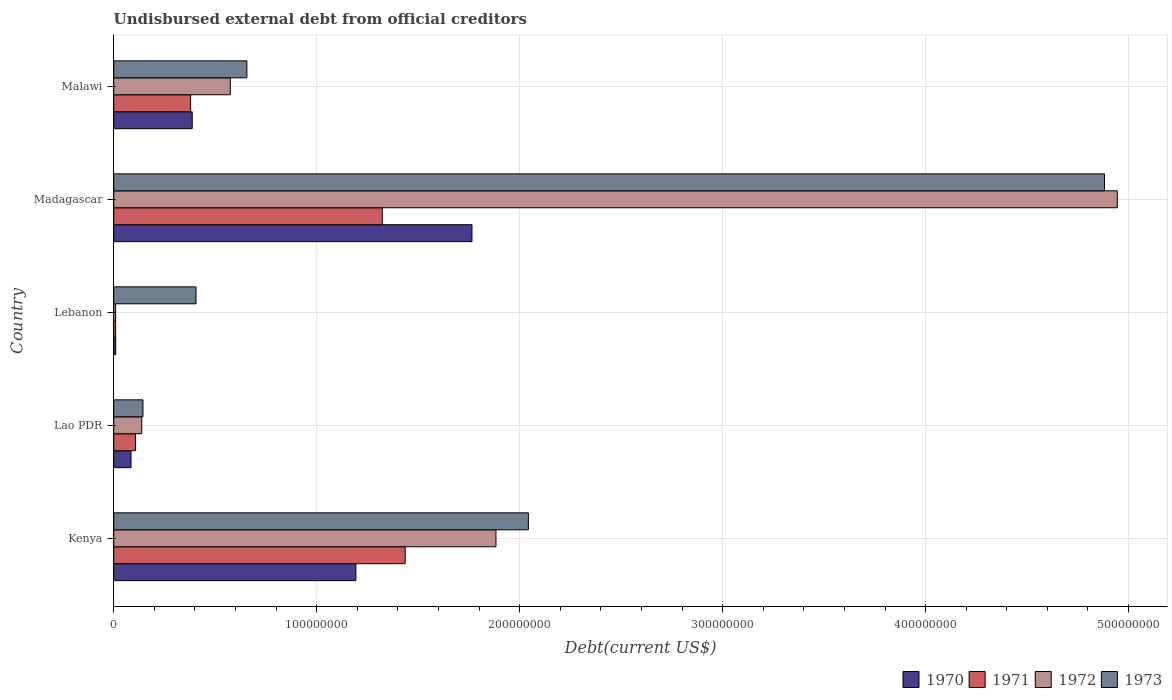Are the number of bars per tick equal to the number of legend labels?
Ensure brevity in your answer.  Yes. Are the number of bars on each tick of the Y-axis equal?
Your response must be concise. Yes. How many bars are there on the 4th tick from the bottom?
Keep it short and to the point. 4. What is the label of the 2nd group of bars from the top?
Ensure brevity in your answer.  Madagascar. In how many cases, is the number of bars for a given country not equal to the number of legend labels?
Offer a terse response. 0. What is the total debt in 1972 in Malawi?
Ensure brevity in your answer.  5.74e+07. Across all countries, what is the maximum total debt in 1971?
Your response must be concise. 1.44e+08. Across all countries, what is the minimum total debt in 1971?
Give a very brief answer. 9.32e+05. In which country was the total debt in 1970 maximum?
Your answer should be very brief. Madagascar. In which country was the total debt in 1970 minimum?
Make the answer very short. Lebanon. What is the total total debt in 1973 in the graph?
Make the answer very short. 8.13e+08. What is the difference between the total debt in 1970 in Lebanon and that in Madagascar?
Offer a very short reply. -1.76e+08. What is the difference between the total debt in 1973 in Lao PDR and the total debt in 1972 in Kenya?
Offer a very short reply. -1.74e+08. What is the average total debt in 1973 per country?
Provide a short and direct response. 1.63e+08. What is the difference between the total debt in 1972 and total debt in 1971 in Lao PDR?
Your answer should be very brief. 3.08e+06. In how many countries, is the total debt in 1973 greater than 440000000 US$?
Make the answer very short. 1. What is the ratio of the total debt in 1973 in Kenya to that in Madagascar?
Your answer should be very brief. 0.42. What is the difference between the highest and the second highest total debt in 1971?
Offer a very short reply. 1.13e+07. What is the difference between the highest and the lowest total debt in 1972?
Offer a terse response. 4.94e+08. In how many countries, is the total debt in 1970 greater than the average total debt in 1970 taken over all countries?
Your answer should be very brief. 2. Is the sum of the total debt in 1971 in Kenya and Malawi greater than the maximum total debt in 1973 across all countries?
Offer a terse response. No. What does the 4th bar from the top in Madagascar represents?
Offer a very short reply. 1970. What does the 3rd bar from the bottom in Malawi represents?
Give a very brief answer. 1972. Is it the case that in every country, the sum of the total debt in 1970 and total debt in 1972 is greater than the total debt in 1971?
Your answer should be very brief. Yes. How many countries are there in the graph?
Offer a very short reply. 5. Does the graph contain any zero values?
Offer a terse response. No. Does the graph contain grids?
Make the answer very short. Yes. What is the title of the graph?
Provide a succinct answer. Undisbursed external debt from official creditors. What is the label or title of the X-axis?
Offer a very short reply. Debt(current US$). What is the Debt(current US$) of 1970 in Kenya?
Make the answer very short. 1.19e+08. What is the Debt(current US$) in 1971 in Kenya?
Your answer should be very brief. 1.44e+08. What is the Debt(current US$) in 1972 in Kenya?
Make the answer very short. 1.88e+08. What is the Debt(current US$) in 1973 in Kenya?
Offer a very short reply. 2.04e+08. What is the Debt(current US$) of 1970 in Lao PDR?
Keep it short and to the point. 8.52e+06. What is the Debt(current US$) in 1971 in Lao PDR?
Ensure brevity in your answer.  1.07e+07. What is the Debt(current US$) of 1972 in Lao PDR?
Offer a terse response. 1.38e+07. What is the Debt(current US$) in 1973 in Lao PDR?
Provide a short and direct response. 1.44e+07. What is the Debt(current US$) in 1970 in Lebanon?
Provide a short and direct response. 9.80e+05. What is the Debt(current US$) in 1971 in Lebanon?
Offer a very short reply. 9.32e+05. What is the Debt(current US$) of 1972 in Lebanon?
Your answer should be compact. 9.32e+05. What is the Debt(current US$) of 1973 in Lebanon?
Offer a terse response. 4.05e+07. What is the Debt(current US$) in 1970 in Madagascar?
Offer a very short reply. 1.76e+08. What is the Debt(current US$) of 1971 in Madagascar?
Your response must be concise. 1.32e+08. What is the Debt(current US$) of 1972 in Madagascar?
Your answer should be very brief. 4.94e+08. What is the Debt(current US$) in 1973 in Madagascar?
Offer a terse response. 4.88e+08. What is the Debt(current US$) in 1970 in Malawi?
Offer a very short reply. 3.87e+07. What is the Debt(current US$) in 1971 in Malawi?
Your answer should be compact. 3.79e+07. What is the Debt(current US$) in 1972 in Malawi?
Your answer should be compact. 5.74e+07. What is the Debt(current US$) in 1973 in Malawi?
Ensure brevity in your answer.  6.56e+07. Across all countries, what is the maximum Debt(current US$) in 1970?
Give a very brief answer. 1.76e+08. Across all countries, what is the maximum Debt(current US$) of 1971?
Provide a succinct answer. 1.44e+08. Across all countries, what is the maximum Debt(current US$) in 1972?
Your answer should be very brief. 4.94e+08. Across all countries, what is the maximum Debt(current US$) in 1973?
Make the answer very short. 4.88e+08. Across all countries, what is the minimum Debt(current US$) of 1970?
Make the answer very short. 9.80e+05. Across all countries, what is the minimum Debt(current US$) in 1971?
Your answer should be very brief. 9.32e+05. Across all countries, what is the minimum Debt(current US$) in 1972?
Keep it short and to the point. 9.32e+05. Across all countries, what is the minimum Debt(current US$) in 1973?
Make the answer very short. 1.44e+07. What is the total Debt(current US$) in 1970 in the graph?
Ensure brevity in your answer.  3.44e+08. What is the total Debt(current US$) of 1971 in the graph?
Offer a terse response. 3.25e+08. What is the total Debt(current US$) in 1972 in the graph?
Provide a succinct answer. 7.55e+08. What is the total Debt(current US$) in 1973 in the graph?
Keep it short and to the point. 8.13e+08. What is the difference between the Debt(current US$) of 1970 in Kenya and that in Lao PDR?
Provide a succinct answer. 1.11e+08. What is the difference between the Debt(current US$) of 1971 in Kenya and that in Lao PDR?
Your response must be concise. 1.33e+08. What is the difference between the Debt(current US$) of 1972 in Kenya and that in Lao PDR?
Your answer should be very brief. 1.75e+08. What is the difference between the Debt(current US$) of 1973 in Kenya and that in Lao PDR?
Keep it short and to the point. 1.90e+08. What is the difference between the Debt(current US$) of 1970 in Kenya and that in Lebanon?
Give a very brief answer. 1.18e+08. What is the difference between the Debt(current US$) of 1971 in Kenya and that in Lebanon?
Provide a succinct answer. 1.43e+08. What is the difference between the Debt(current US$) in 1972 in Kenya and that in Lebanon?
Provide a short and direct response. 1.87e+08. What is the difference between the Debt(current US$) in 1973 in Kenya and that in Lebanon?
Your answer should be very brief. 1.64e+08. What is the difference between the Debt(current US$) in 1970 in Kenya and that in Madagascar?
Provide a short and direct response. -5.72e+07. What is the difference between the Debt(current US$) in 1971 in Kenya and that in Madagascar?
Your answer should be compact. 1.13e+07. What is the difference between the Debt(current US$) of 1972 in Kenya and that in Madagascar?
Give a very brief answer. -3.06e+08. What is the difference between the Debt(current US$) in 1973 in Kenya and that in Madagascar?
Ensure brevity in your answer.  -2.84e+08. What is the difference between the Debt(current US$) in 1970 in Kenya and that in Malawi?
Keep it short and to the point. 8.06e+07. What is the difference between the Debt(current US$) of 1971 in Kenya and that in Malawi?
Your answer should be very brief. 1.06e+08. What is the difference between the Debt(current US$) of 1972 in Kenya and that in Malawi?
Offer a terse response. 1.31e+08. What is the difference between the Debt(current US$) of 1973 in Kenya and that in Malawi?
Make the answer very short. 1.39e+08. What is the difference between the Debt(current US$) of 1970 in Lao PDR and that in Lebanon?
Make the answer very short. 7.54e+06. What is the difference between the Debt(current US$) in 1971 in Lao PDR and that in Lebanon?
Offer a terse response. 9.78e+06. What is the difference between the Debt(current US$) of 1972 in Lao PDR and that in Lebanon?
Make the answer very short. 1.29e+07. What is the difference between the Debt(current US$) in 1973 in Lao PDR and that in Lebanon?
Make the answer very short. -2.61e+07. What is the difference between the Debt(current US$) in 1970 in Lao PDR and that in Madagascar?
Offer a very short reply. -1.68e+08. What is the difference between the Debt(current US$) of 1971 in Lao PDR and that in Madagascar?
Ensure brevity in your answer.  -1.22e+08. What is the difference between the Debt(current US$) in 1972 in Lao PDR and that in Madagascar?
Ensure brevity in your answer.  -4.81e+08. What is the difference between the Debt(current US$) of 1973 in Lao PDR and that in Madagascar?
Provide a succinct answer. -4.74e+08. What is the difference between the Debt(current US$) of 1970 in Lao PDR and that in Malawi?
Provide a short and direct response. -3.01e+07. What is the difference between the Debt(current US$) in 1971 in Lao PDR and that in Malawi?
Your response must be concise. -2.72e+07. What is the difference between the Debt(current US$) of 1972 in Lao PDR and that in Malawi?
Ensure brevity in your answer.  -4.36e+07. What is the difference between the Debt(current US$) in 1973 in Lao PDR and that in Malawi?
Provide a short and direct response. -5.12e+07. What is the difference between the Debt(current US$) in 1970 in Lebanon and that in Madagascar?
Your response must be concise. -1.76e+08. What is the difference between the Debt(current US$) of 1971 in Lebanon and that in Madagascar?
Give a very brief answer. -1.31e+08. What is the difference between the Debt(current US$) in 1972 in Lebanon and that in Madagascar?
Give a very brief answer. -4.94e+08. What is the difference between the Debt(current US$) in 1973 in Lebanon and that in Madagascar?
Give a very brief answer. -4.48e+08. What is the difference between the Debt(current US$) in 1970 in Lebanon and that in Malawi?
Provide a succinct answer. -3.77e+07. What is the difference between the Debt(current US$) in 1971 in Lebanon and that in Malawi?
Give a very brief answer. -3.70e+07. What is the difference between the Debt(current US$) in 1972 in Lebanon and that in Malawi?
Offer a very short reply. -5.65e+07. What is the difference between the Debt(current US$) in 1973 in Lebanon and that in Malawi?
Provide a short and direct response. -2.51e+07. What is the difference between the Debt(current US$) of 1970 in Madagascar and that in Malawi?
Give a very brief answer. 1.38e+08. What is the difference between the Debt(current US$) of 1971 in Madagascar and that in Malawi?
Your answer should be very brief. 9.44e+07. What is the difference between the Debt(current US$) of 1972 in Madagascar and that in Malawi?
Keep it short and to the point. 4.37e+08. What is the difference between the Debt(current US$) in 1973 in Madagascar and that in Malawi?
Provide a short and direct response. 4.23e+08. What is the difference between the Debt(current US$) in 1970 in Kenya and the Debt(current US$) in 1971 in Lao PDR?
Offer a very short reply. 1.09e+08. What is the difference between the Debt(current US$) of 1970 in Kenya and the Debt(current US$) of 1972 in Lao PDR?
Offer a very short reply. 1.05e+08. What is the difference between the Debt(current US$) of 1970 in Kenya and the Debt(current US$) of 1973 in Lao PDR?
Your answer should be compact. 1.05e+08. What is the difference between the Debt(current US$) in 1971 in Kenya and the Debt(current US$) in 1972 in Lao PDR?
Your answer should be compact. 1.30e+08. What is the difference between the Debt(current US$) in 1971 in Kenya and the Debt(current US$) in 1973 in Lao PDR?
Your answer should be compact. 1.29e+08. What is the difference between the Debt(current US$) of 1972 in Kenya and the Debt(current US$) of 1973 in Lao PDR?
Make the answer very short. 1.74e+08. What is the difference between the Debt(current US$) of 1970 in Kenya and the Debt(current US$) of 1971 in Lebanon?
Ensure brevity in your answer.  1.18e+08. What is the difference between the Debt(current US$) of 1970 in Kenya and the Debt(current US$) of 1972 in Lebanon?
Offer a terse response. 1.18e+08. What is the difference between the Debt(current US$) in 1970 in Kenya and the Debt(current US$) in 1973 in Lebanon?
Provide a succinct answer. 7.88e+07. What is the difference between the Debt(current US$) in 1971 in Kenya and the Debt(current US$) in 1972 in Lebanon?
Your response must be concise. 1.43e+08. What is the difference between the Debt(current US$) of 1971 in Kenya and the Debt(current US$) of 1973 in Lebanon?
Your answer should be very brief. 1.03e+08. What is the difference between the Debt(current US$) in 1972 in Kenya and the Debt(current US$) in 1973 in Lebanon?
Give a very brief answer. 1.48e+08. What is the difference between the Debt(current US$) in 1970 in Kenya and the Debt(current US$) in 1971 in Madagascar?
Your answer should be compact. -1.30e+07. What is the difference between the Debt(current US$) in 1970 in Kenya and the Debt(current US$) in 1972 in Madagascar?
Provide a succinct answer. -3.75e+08. What is the difference between the Debt(current US$) in 1970 in Kenya and the Debt(current US$) in 1973 in Madagascar?
Make the answer very short. -3.69e+08. What is the difference between the Debt(current US$) of 1971 in Kenya and the Debt(current US$) of 1972 in Madagascar?
Your answer should be very brief. -3.51e+08. What is the difference between the Debt(current US$) in 1971 in Kenya and the Debt(current US$) in 1973 in Madagascar?
Offer a very short reply. -3.45e+08. What is the difference between the Debt(current US$) in 1972 in Kenya and the Debt(current US$) in 1973 in Madagascar?
Offer a terse response. -3.00e+08. What is the difference between the Debt(current US$) in 1970 in Kenya and the Debt(current US$) in 1971 in Malawi?
Give a very brief answer. 8.14e+07. What is the difference between the Debt(current US$) of 1970 in Kenya and the Debt(current US$) of 1972 in Malawi?
Offer a terse response. 6.19e+07. What is the difference between the Debt(current US$) of 1970 in Kenya and the Debt(current US$) of 1973 in Malawi?
Provide a short and direct response. 5.37e+07. What is the difference between the Debt(current US$) in 1971 in Kenya and the Debt(current US$) in 1972 in Malawi?
Provide a succinct answer. 8.62e+07. What is the difference between the Debt(current US$) of 1971 in Kenya and the Debt(current US$) of 1973 in Malawi?
Your answer should be very brief. 7.80e+07. What is the difference between the Debt(current US$) in 1972 in Kenya and the Debt(current US$) in 1973 in Malawi?
Make the answer very short. 1.23e+08. What is the difference between the Debt(current US$) of 1970 in Lao PDR and the Debt(current US$) of 1971 in Lebanon?
Give a very brief answer. 7.59e+06. What is the difference between the Debt(current US$) in 1970 in Lao PDR and the Debt(current US$) in 1972 in Lebanon?
Keep it short and to the point. 7.59e+06. What is the difference between the Debt(current US$) of 1970 in Lao PDR and the Debt(current US$) of 1973 in Lebanon?
Your answer should be compact. -3.20e+07. What is the difference between the Debt(current US$) in 1971 in Lao PDR and the Debt(current US$) in 1972 in Lebanon?
Ensure brevity in your answer.  9.78e+06. What is the difference between the Debt(current US$) of 1971 in Lao PDR and the Debt(current US$) of 1973 in Lebanon?
Ensure brevity in your answer.  -2.98e+07. What is the difference between the Debt(current US$) of 1972 in Lao PDR and the Debt(current US$) of 1973 in Lebanon?
Make the answer very short. -2.67e+07. What is the difference between the Debt(current US$) in 1970 in Lao PDR and the Debt(current US$) in 1971 in Madagascar?
Provide a succinct answer. -1.24e+08. What is the difference between the Debt(current US$) of 1970 in Lao PDR and the Debt(current US$) of 1972 in Madagascar?
Your answer should be very brief. -4.86e+08. What is the difference between the Debt(current US$) of 1970 in Lao PDR and the Debt(current US$) of 1973 in Madagascar?
Your answer should be compact. -4.80e+08. What is the difference between the Debt(current US$) in 1971 in Lao PDR and the Debt(current US$) in 1972 in Madagascar?
Provide a short and direct response. -4.84e+08. What is the difference between the Debt(current US$) of 1971 in Lao PDR and the Debt(current US$) of 1973 in Madagascar?
Give a very brief answer. -4.77e+08. What is the difference between the Debt(current US$) of 1972 in Lao PDR and the Debt(current US$) of 1973 in Madagascar?
Your answer should be compact. -4.74e+08. What is the difference between the Debt(current US$) in 1970 in Lao PDR and the Debt(current US$) in 1971 in Malawi?
Ensure brevity in your answer.  -2.94e+07. What is the difference between the Debt(current US$) in 1970 in Lao PDR and the Debt(current US$) in 1972 in Malawi?
Keep it short and to the point. -4.89e+07. What is the difference between the Debt(current US$) of 1970 in Lao PDR and the Debt(current US$) of 1973 in Malawi?
Provide a succinct answer. -5.71e+07. What is the difference between the Debt(current US$) of 1971 in Lao PDR and the Debt(current US$) of 1972 in Malawi?
Your answer should be compact. -4.67e+07. What is the difference between the Debt(current US$) of 1971 in Lao PDR and the Debt(current US$) of 1973 in Malawi?
Your answer should be compact. -5.49e+07. What is the difference between the Debt(current US$) in 1972 in Lao PDR and the Debt(current US$) in 1973 in Malawi?
Your response must be concise. -5.18e+07. What is the difference between the Debt(current US$) of 1970 in Lebanon and the Debt(current US$) of 1971 in Madagascar?
Your answer should be very brief. -1.31e+08. What is the difference between the Debt(current US$) in 1970 in Lebanon and the Debt(current US$) in 1972 in Madagascar?
Your answer should be very brief. -4.93e+08. What is the difference between the Debt(current US$) of 1970 in Lebanon and the Debt(current US$) of 1973 in Madagascar?
Your response must be concise. -4.87e+08. What is the difference between the Debt(current US$) in 1971 in Lebanon and the Debt(current US$) in 1972 in Madagascar?
Your response must be concise. -4.94e+08. What is the difference between the Debt(current US$) of 1971 in Lebanon and the Debt(current US$) of 1973 in Madagascar?
Keep it short and to the point. -4.87e+08. What is the difference between the Debt(current US$) of 1972 in Lebanon and the Debt(current US$) of 1973 in Madagascar?
Offer a very short reply. -4.87e+08. What is the difference between the Debt(current US$) in 1970 in Lebanon and the Debt(current US$) in 1971 in Malawi?
Provide a succinct answer. -3.69e+07. What is the difference between the Debt(current US$) of 1970 in Lebanon and the Debt(current US$) of 1972 in Malawi?
Your answer should be compact. -5.64e+07. What is the difference between the Debt(current US$) in 1970 in Lebanon and the Debt(current US$) in 1973 in Malawi?
Ensure brevity in your answer.  -6.46e+07. What is the difference between the Debt(current US$) in 1971 in Lebanon and the Debt(current US$) in 1972 in Malawi?
Provide a short and direct response. -5.65e+07. What is the difference between the Debt(current US$) of 1971 in Lebanon and the Debt(current US$) of 1973 in Malawi?
Ensure brevity in your answer.  -6.47e+07. What is the difference between the Debt(current US$) of 1972 in Lebanon and the Debt(current US$) of 1973 in Malawi?
Give a very brief answer. -6.47e+07. What is the difference between the Debt(current US$) in 1970 in Madagascar and the Debt(current US$) in 1971 in Malawi?
Give a very brief answer. 1.39e+08. What is the difference between the Debt(current US$) in 1970 in Madagascar and the Debt(current US$) in 1972 in Malawi?
Give a very brief answer. 1.19e+08. What is the difference between the Debt(current US$) in 1970 in Madagascar and the Debt(current US$) in 1973 in Malawi?
Keep it short and to the point. 1.11e+08. What is the difference between the Debt(current US$) in 1971 in Madagascar and the Debt(current US$) in 1972 in Malawi?
Ensure brevity in your answer.  7.49e+07. What is the difference between the Debt(current US$) in 1971 in Madagascar and the Debt(current US$) in 1973 in Malawi?
Provide a short and direct response. 6.67e+07. What is the difference between the Debt(current US$) in 1972 in Madagascar and the Debt(current US$) in 1973 in Malawi?
Your response must be concise. 4.29e+08. What is the average Debt(current US$) of 1970 per country?
Give a very brief answer. 6.88e+07. What is the average Debt(current US$) of 1971 per country?
Your answer should be very brief. 6.51e+07. What is the average Debt(current US$) in 1972 per country?
Offer a terse response. 1.51e+08. What is the average Debt(current US$) in 1973 per country?
Make the answer very short. 1.63e+08. What is the difference between the Debt(current US$) of 1970 and Debt(current US$) of 1971 in Kenya?
Ensure brevity in your answer.  -2.43e+07. What is the difference between the Debt(current US$) in 1970 and Debt(current US$) in 1972 in Kenya?
Ensure brevity in your answer.  -6.90e+07. What is the difference between the Debt(current US$) of 1970 and Debt(current US$) of 1973 in Kenya?
Your answer should be very brief. -8.50e+07. What is the difference between the Debt(current US$) of 1971 and Debt(current US$) of 1972 in Kenya?
Ensure brevity in your answer.  -4.47e+07. What is the difference between the Debt(current US$) in 1971 and Debt(current US$) in 1973 in Kenya?
Ensure brevity in your answer.  -6.07e+07. What is the difference between the Debt(current US$) in 1972 and Debt(current US$) in 1973 in Kenya?
Provide a short and direct response. -1.60e+07. What is the difference between the Debt(current US$) of 1970 and Debt(current US$) of 1971 in Lao PDR?
Your answer should be very brief. -2.19e+06. What is the difference between the Debt(current US$) of 1970 and Debt(current US$) of 1972 in Lao PDR?
Make the answer very short. -5.28e+06. What is the difference between the Debt(current US$) in 1970 and Debt(current US$) in 1973 in Lao PDR?
Give a very brief answer. -5.88e+06. What is the difference between the Debt(current US$) of 1971 and Debt(current US$) of 1972 in Lao PDR?
Your answer should be very brief. -3.08e+06. What is the difference between the Debt(current US$) in 1971 and Debt(current US$) in 1973 in Lao PDR?
Give a very brief answer. -3.69e+06. What is the difference between the Debt(current US$) of 1972 and Debt(current US$) of 1973 in Lao PDR?
Offer a very short reply. -6.01e+05. What is the difference between the Debt(current US$) in 1970 and Debt(current US$) in 1971 in Lebanon?
Ensure brevity in your answer.  4.80e+04. What is the difference between the Debt(current US$) of 1970 and Debt(current US$) of 1972 in Lebanon?
Give a very brief answer. 4.80e+04. What is the difference between the Debt(current US$) in 1970 and Debt(current US$) in 1973 in Lebanon?
Your answer should be compact. -3.96e+07. What is the difference between the Debt(current US$) in 1971 and Debt(current US$) in 1973 in Lebanon?
Offer a very short reply. -3.96e+07. What is the difference between the Debt(current US$) of 1972 and Debt(current US$) of 1973 in Lebanon?
Provide a short and direct response. -3.96e+07. What is the difference between the Debt(current US$) in 1970 and Debt(current US$) in 1971 in Madagascar?
Provide a succinct answer. 4.42e+07. What is the difference between the Debt(current US$) in 1970 and Debt(current US$) in 1972 in Madagascar?
Your response must be concise. -3.18e+08. What is the difference between the Debt(current US$) of 1970 and Debt(current US$) of 1973 in Madagascar?
Your response must be concise. -3.12e+08. What is the difference between the Debt(current US$) of 1971 and Debt(current US$) of 1972 in Madagascar?
Ensure brevity in your answer.  -3.62e+08. What is the difference between the Debt(current US$) of 1971 and Debt(current US$) of 1973 in Madagascar?
Ensure brevity in your answer.  -3.56e+08. What is the difference between the Debt(current US$) of 1972 and Debt(current US$) of 1973 in Madagascar?
Make the answer very short. 6.33e+06. What is the difference between the Debt(current US$) of 1970 and Debt(current US$) of 1971 in Malawi?
Your answer should be very brief. 7.85e+05. What is the difference between the Debt(current US$) in 1970 and Debt(current US$) in 1972 in Malawi?
Provide a succinct answer. -1.88e+07. What is the difference between the Debt(current US$) in 1970 and Debt(current US$) in 1973 in Malawi?
Your answer should be very brief. -2.69e+07. What is the difference between the Debt(current US$) of 1971 and Debt(current US$) of 1972 in Malawi?
Give a very brief answer. -1.95e+07. What is the difference between the Debt(current US$) of 1971 and Debt(current US$) of 1973 in Malawi?
Make the answer very short. -2.77e+07. What is the difference between the Debt(current US$) of 1972 and Debt(current US$) of 1973 in Malawi?
Keep it short and to the point. -8.17e+06. What is the ratio of the Debt(current US$) in 1970 in Kenya to that in Lao PDR?
Provide a short and direct response. 14. What is the ratio of the Debt(current US$) of 1971 in Kenya to that in Lao PDR?
Give a very brief answer. 13.41. What is the ratio of the Debt(current US$) of 1972 in Kenya to that in Lao PDR?
Your response must be concise. 13.65. What is the ratio of the Debt(current US$) in 1973 in Kenya to that in Lao PDR?
Provide a short and direct response. 14.19. What is the ratio of the Debt(current US$) of 1970 in Kenya to that in Lebanon?
Your answer should be very brief. 121.73. What is the ratio of the Debt(current US$) in 1971 in Kenya to that in Lebanon?
Ensure brevity in your answer.  154.08. What is the ratio of the Debt(current US$) of 1972 in Kenya to that in Lebanon?
Offer a terse response. 202.06. What is the ratio of the Debt(current US$) in 1973 in Kenya to that in Lebanon?
Provide a short and direct response. 5.04. What is the ratio of the Debt(current US$) of 1970 in Kenya to that in Madagascar?
Give a very brief answer. 0.68. What is the ratio of the Debt(current US$) of 1971 in Kenya to that in Madagascar?
Provide a succinct answer. 1.09. What is the ratio of the Debt(current US$) in 1972 in Kenya to that in Madagascar?
Provide a succinct answer. 0.38. What is the ratio of the Debt(current US$) of 1973 in Kenya to that in Madagascar?
Provide a succinct answer. 0.42. What is the ratio of the Debt(current US$) of 1970 in Kenya to that in Malawi?
Offer a terse response. 3.09. What is the ratio of the Debt(current US$) in 1971 in Kenya to that in Malawi?
Offer a terse response. 3.79. What is the ratio of the Debt(current US$) in 1972 in Kenya to that in Malawi?
Your answer should be very brief. 3.28. What is the ratio of the Debt(current US$) of 1973 in Kenya to that in Malawi?
Your answer should be compact. 3.11. What is the ratio of the Debt(current US$) of 1970 in Lao PDR to that in Lebanon?
Provide a succinct answer. 8.69. What is the ratio of the Debt(current US$) in 1971 in Lao PDR to that in Lebanon?
Offer a very short reply. 11.49. What is the ratio of the Debt(current US$) in 1972 in Lao PDR to that in Lebanon?
Your answer should be compact. 14.8. What is the ratio of the Debt(current US$) in 1973 in Lao PDR to that in Lebanon?
Provide a succinct answer. 0.36. What is the ratio of the Debt(current US$) in 1970 in Lao PDR to that in Madagascar?
Your answer should be very brief. 0.05. What is the ratio of the Debt(current US$) in 1971 in Lao PDR to that in Madagascar?
Make the answer very short. 0.08. What is the ratio of the Debt(current US$) in 1972 in Lao PDR to that in Madagascar?
Keep it short and to the point. 0.03. What is the ratio of the Debt(current US$) in 1973 in Lao PDR to that in Madagascar?
Ensure brevity in your answer.  0.03. What is the ratio of the Debt(current US$) of 1970 in Lao PDR to that in Malawi?
Keep it short and to the point. 0.22. What is the ratio of the Debt(current US$) of 1971 in Lao PDR to that in Malawi?
Offer a terse response. 0.28. What is the ratio of the Debt(current US$) in 1972 in Lao PDR to that in Malawi?
Your answer should be very brief. 0.24. What is the ratio of the Debt(current US$) in 1973 in Lao PDR to that in Malawi?
Offer a very short reply. 0.22. What is the ratio of the Debt(current US$) in 1970 in Lebanon to that in Madagascar?
Give a very brief answer. 0.01. What is the ratio of the Debt(current US$) in 1971 in Lebanon to that in Madagascar?
Your answer should be compact. 0.01. What is the ratio of the Debt(current US$) of 1972 in Lebanon to that in Madagascar?
Offer a terse response. 0. What is the ratio of the Debt(current US$) in 1973 in Lebanon to that in Madagascar?
Your answer should be very brief. 0.08. What is the ratio of the Debt(current US$) in 1970 in Lebanon to that in Malawi?
Ensure brevity in your answer.  0.03. What is the ratio of the Debt(current US$) of 1971 in Lebanon to that in Malawi?
Offer a terse response. 0.02. What is the ratio of the Debt(current US$) in 1972 in Lebanon to that in Malawi?
Provide a succinct answer. 0.02. What is the ratio of the Debt(current US$) in 1973 in Lebanon to that in Malawi?
Your response must be concise. 0.62. What is the ratio of the Debt(current US$) in 1970 in Madagascar to that in Malawi?
Your answer should be very brief. 4.56. What is the ratio of the Debt(current US$) of 1971 in Madagascar to that in Malawi?
Give a very brief answer. 3.49. What is the ratio of the Debt(current US$) of 1972 in Madagascar to that in Malawi?
Give a very brief answer. 8.61. What is the ratio of the Debt(current US$) in 1973 in Madagascar to that in Malawi?
Provide a succinct answer. 7.44. What is the difference between the highest and the second highest Debt(current US$) of 1970?
Make the answer very short. 5.72e+07. What is the difference between the highest and the second highest Debt(current US$) of 1971?
Make the answer very short. 1.13e+07. What is the difference between the highest and the second highest Debt(current US$) in 1972?
Give a very brief answer. 3.06e+08. What is the difference between the highest and the second highest Debt(current US$) in 1973?
Offer a very short reply. 2.84e+08. What is the difference between the highest and the lowest Debt(current US$) in 1970?
Keep it short and to the point. 1.76e+08. What is the difference between the highest and the lowest Debt(current US$) of 1971?
Make the answer very short. 1.43e+08. What is the difference between the highest and the lowest Debt(current US$) of 1972?
Provide a succinct answer. 4.94e+08. What is the difference between the highest and the lowest Debt(current US$) in 1973?
Provide a succinct answer. 4.74e+08. 